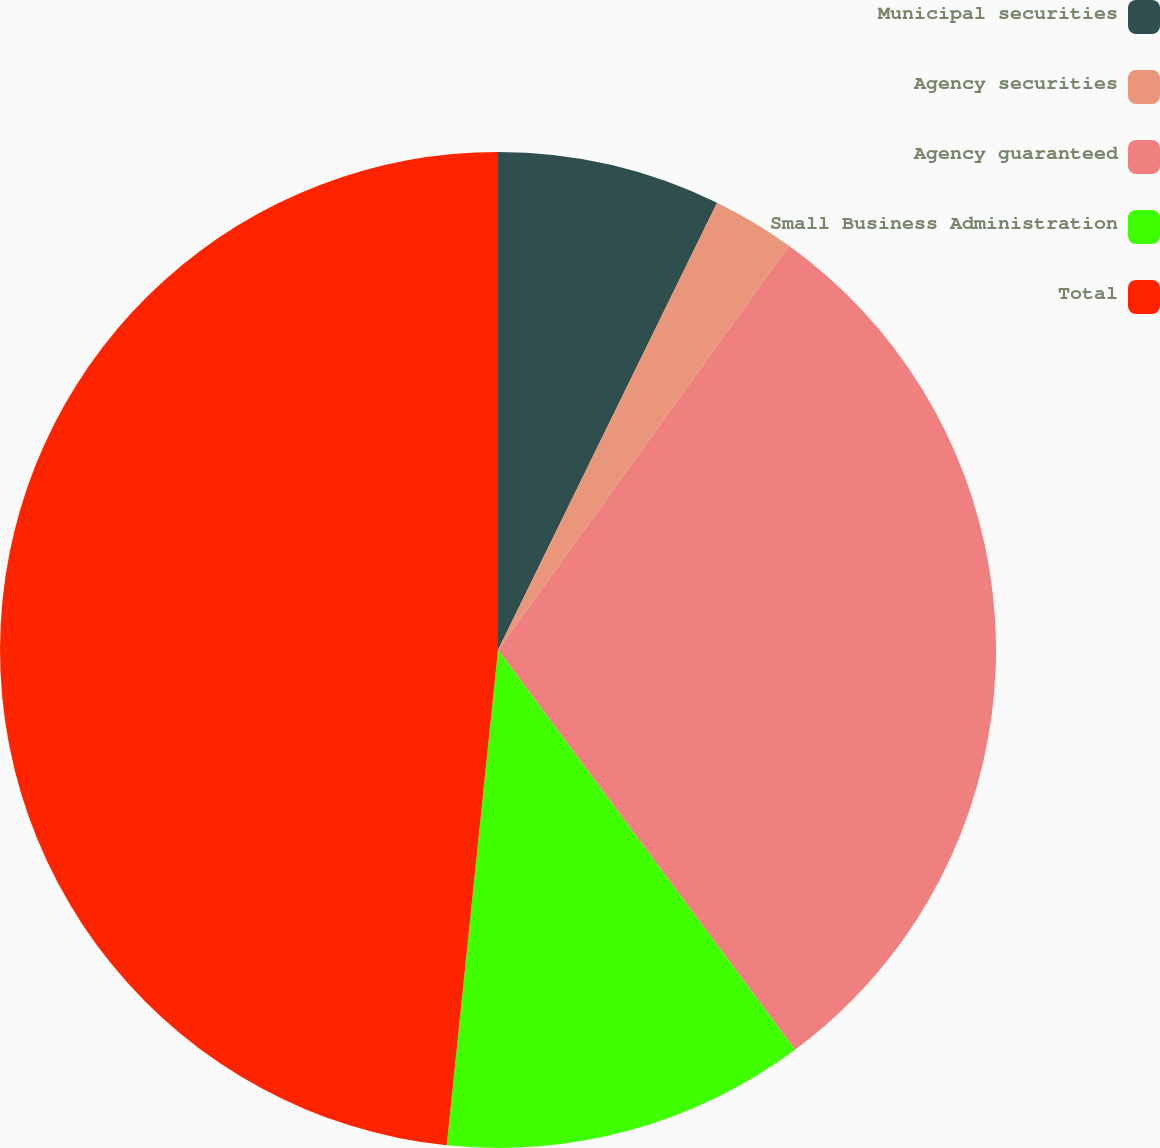<chart> <loc_0><loc_0><loc_500><loc_500><pie_chart><fcel>Municipal securities<fcel>Agency securities<fcel>Agency guaranteed<fcel>Small Business Administration<fcel>Total<nl><fcel>7.25%<fcel>2.68%<fcel>29.9%<fcel>11.81%<fcel>48.36%<nl></chart> 